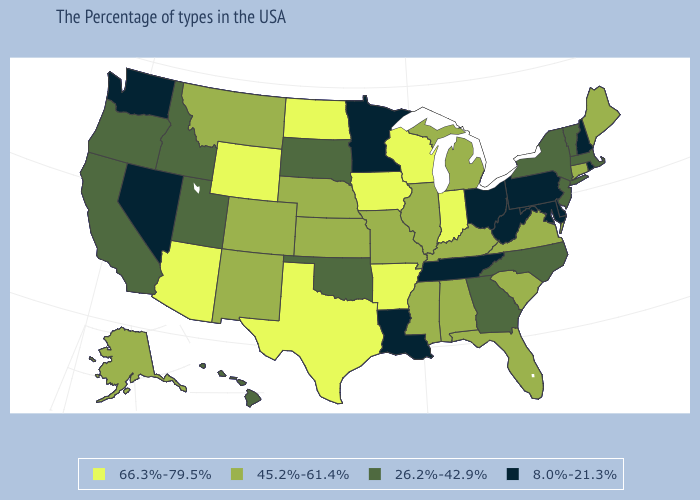What is the highest value in the USA?
Write a very short answer. 66.3%-79.5%. Which states hav the highest value in the Northeast?
Be succinct. Maine, Connecticut. Does North Carolina have the same value as Oregon?
Be succinct. Yes. What is the value of Illinois?
Be succinct. 45.2%-61.4%. Which states have the highest value in the USA?
Give a very brief answer. Indiana, Wisconsin, Arkansas, Iowa, Texas, North Dakota, Wyoming, Arizona. What is the value of Connecticut?
Short answer required. 45.2%-61.4%. Among the states that border West Virginia , does Virginia have the lowest value?
Answer briefly. No. Does Washington have the lowest value in the USA?
Write a very short answer. Yes. What is the value of Michigan?
Give a very brief answer. 45.2%-61.4%. What is the value of Missouri?
Answer briefly. 45.2%-61.4%. Does the first symbol in the legend represent the smallest category?
Give a very brief answer. No. What is the value of West Virginia?
Keep it brief. 8.0%-21.3%. Which states have the highest value in the USA?
Keep it brief. Indiana, Wisconsin, Arkansas, Iowa, Texas, North Dakota, Wyoming, Arizona. Name the states that have a value in the range 66.3%-79.5%?
Be succinct. Indiana, Wisconsin, Arkansas, Iowa, Texas, North Dakota, Wyoming, Arizona. What is the value of Washington?
Write a very short answer. 8.0%-21.3%. 